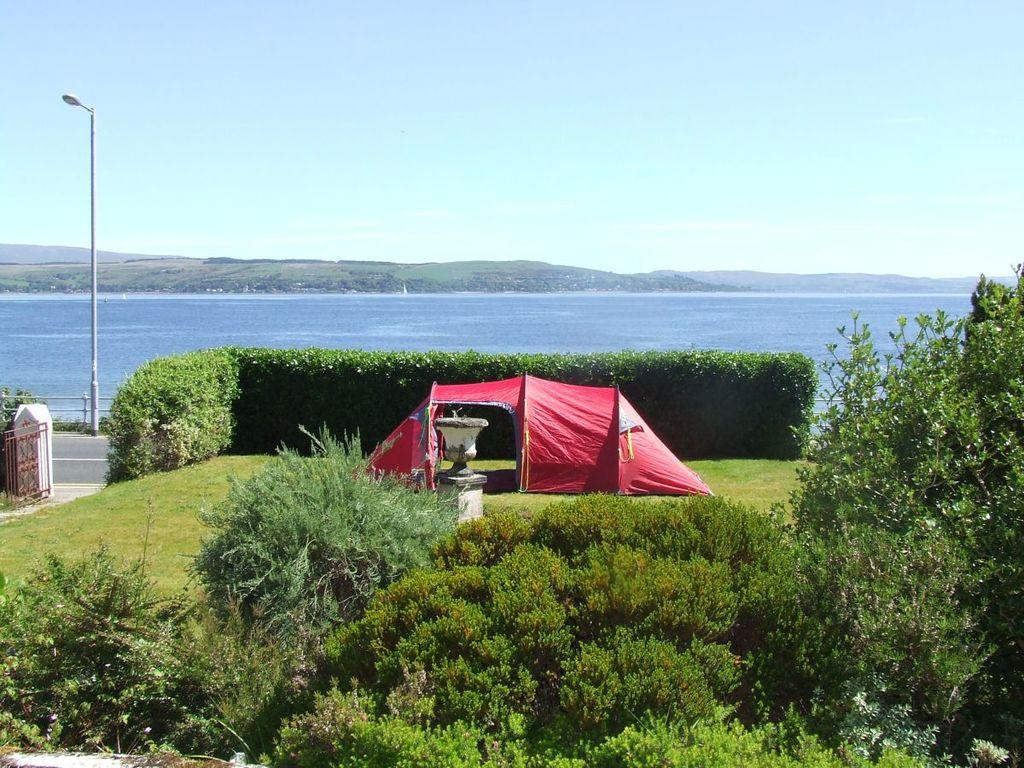What type of vegetation can be seen in the image? There are plants, grass, and trees in the image. What type of shelter is present in the image? There is a tent in the image. What type of entrance is visible in the image? There is a gate in the image. What type of structure is present in the image? There is a pole in the image. What type of illumination is present in the image? There is a light in the image. What type of barrier is visible in the image? There is a fence in the image. What type of liquid is present in the image? There is water in the image. What can be seen in the background of the image? The sky is visible in the background of the image. What route does the car take in the image? There is no car present in the image, so it is not possible to determine a route. What does the person in the image look like? There is no person present in the image, so it is not possible to describe their appearance. 